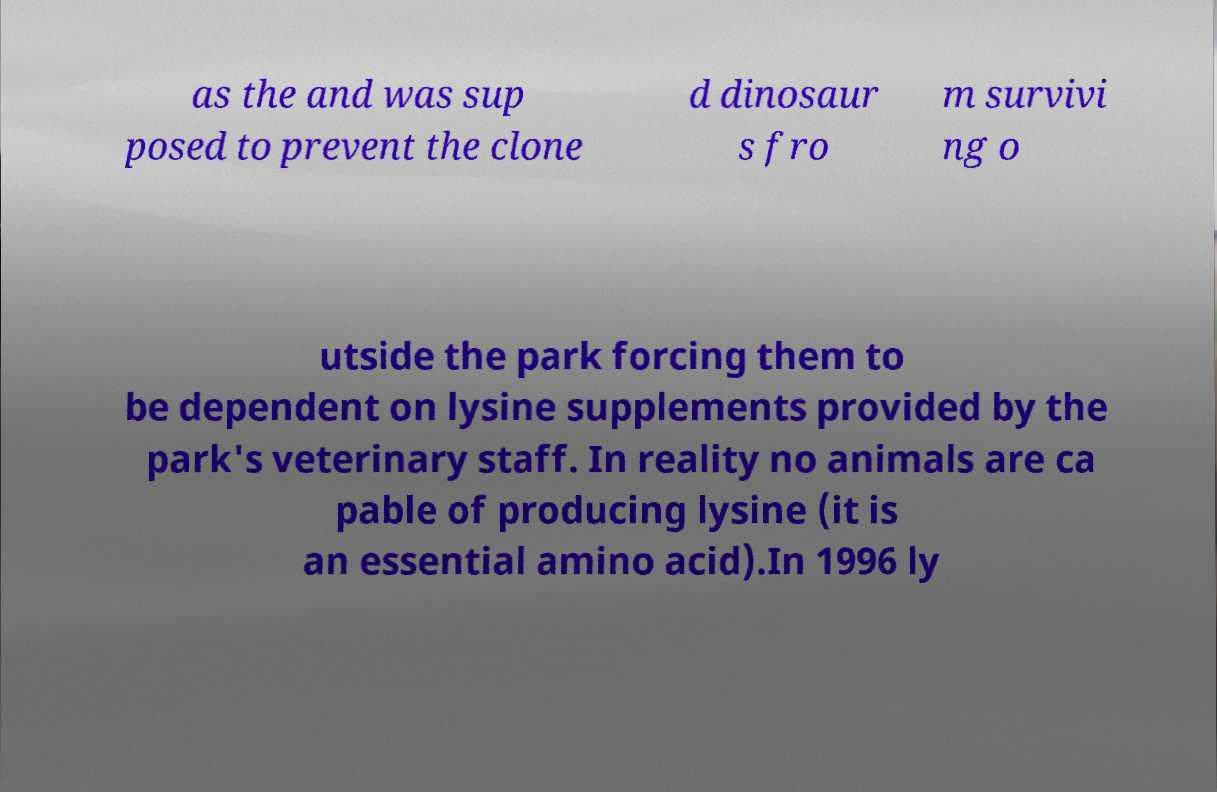For documentation purposes, I need the text within this image transcribed. Could you provide that? as the and was sup posed to prevent the clone d dinosaur s fro m survivi ng o utside the park forcing them to be dependent on lysine supplements provided by the park's veterinary staff. In reality no animals are ca pable of producing lysine (it is an essential amino acid).In 1996 ly 